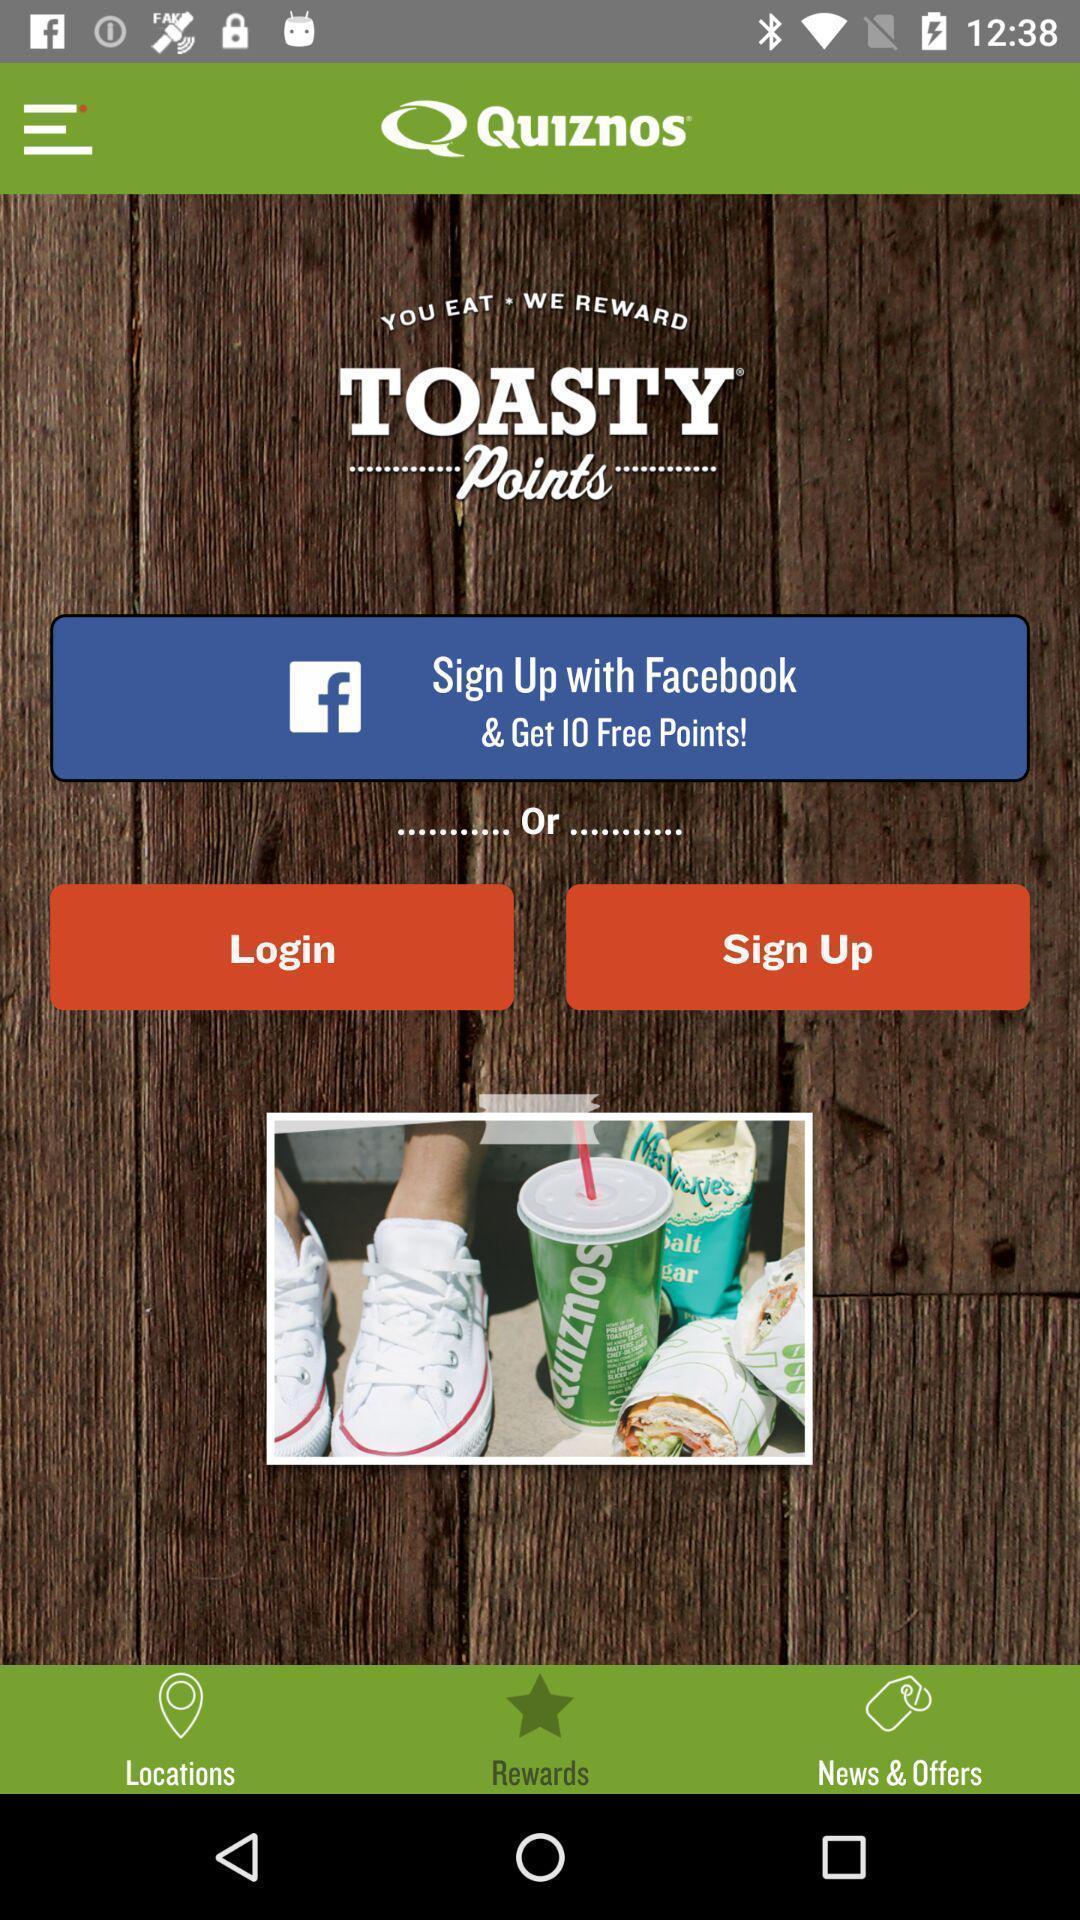Provide a textual representation of this image. Sign up page of toasty points app. 